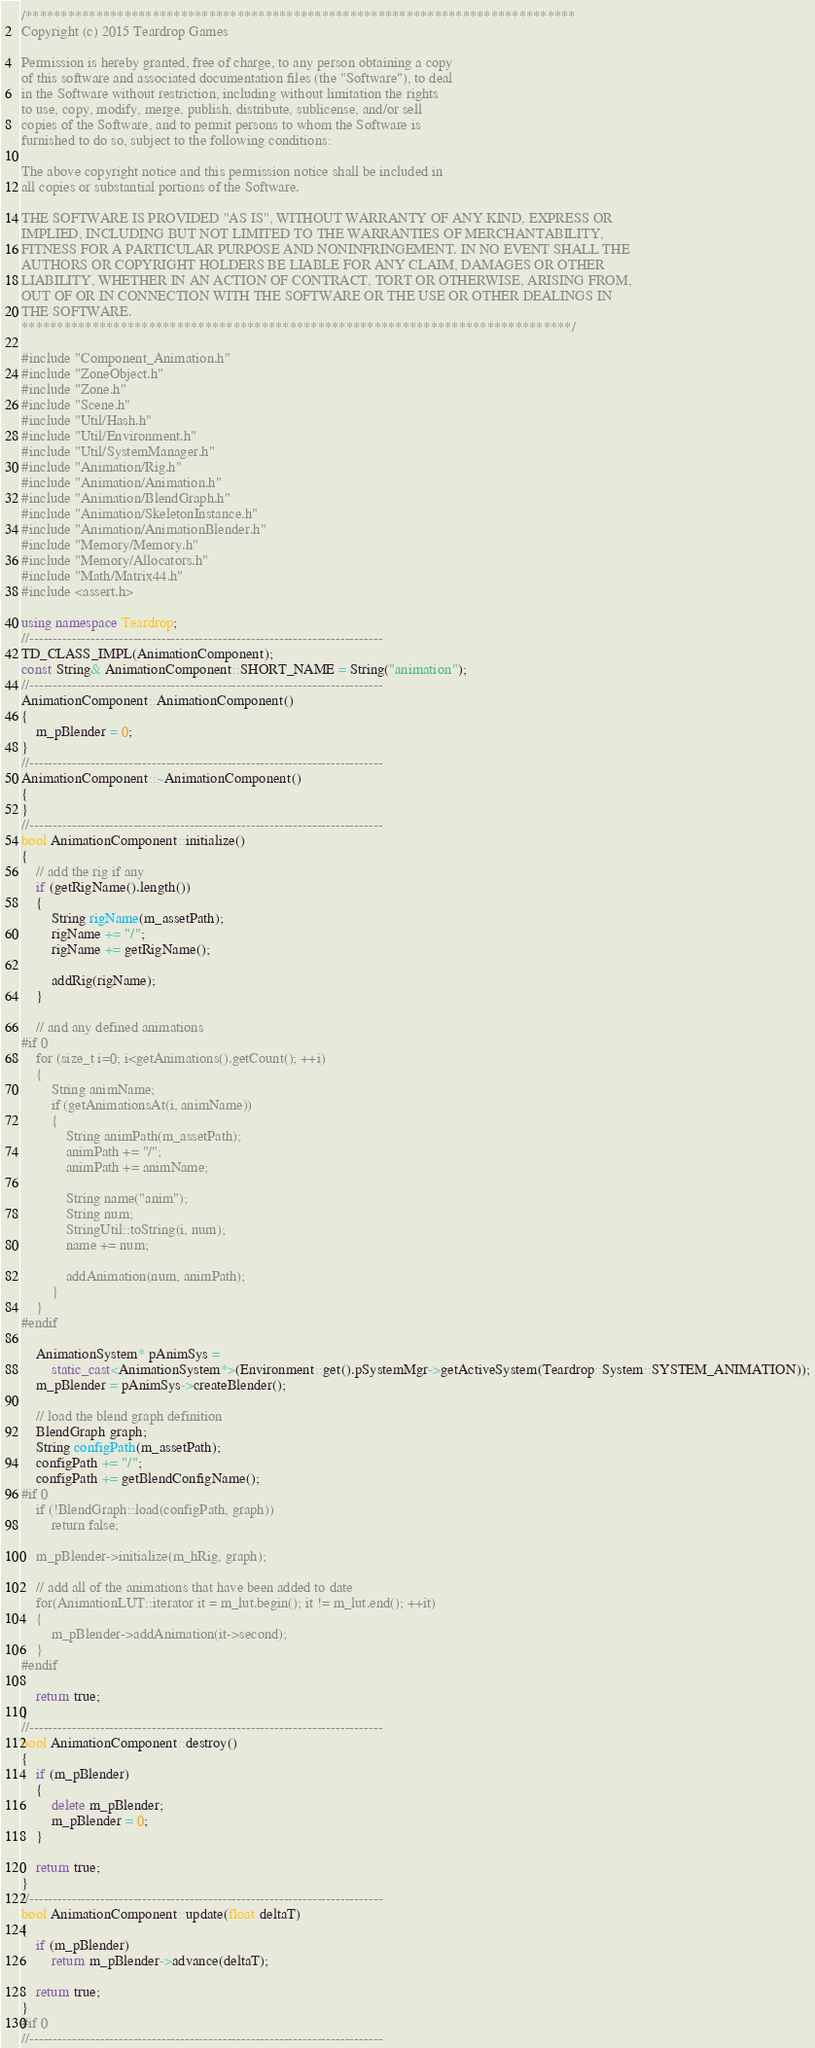<code> <loc_0><loc_0><loc_500><loc_500><_C++_>/******************************************************************************
Copyright (c) 2015 Teardrop Games

Permission is hereby granted, free of charge, to any person obtaining a copy
of this software and associated documentation files (the "Software"), to deal
in the Software without restriction, including without limitation the rights
to use, copy, modify, merge, publish, distribute, sublicense, and/or sell
copies of the Software, and to permit persons to whom the Software is
furnished to do so, subject to the following conditions:

The above copyright notice and this permission notice shall be included in
all copies or substantial portions of the Software.

THE SOFTWARE IS PROVIDED "AS IS", WITHOUT WARRANTY OF ANY KIND, EXPRESS OR
IMPLIED, INCLUDING BUT NOT LIMITED TO THE WARRANTIES OF MERCHANTABILITY,
FITNESS FOR A PARTICULAR PURPOSE AND NONINFRINGEMENT. IN NO EVENT SHALL THE
AUTHORS OR COPYRIGHT HOLDERS BE LIABLE FOR ANY CLAIM, DAMAGES OR OTHER
LIABILITY, WHETHER IN AN ACTION OF CONTRACT, TORT OR OTHERWISE, ARISING FROM,
OUT OF OR IN CONNECTION WITH THE SOFTWARE OR THE USE OR OTHER DEALINGS IN
THE SOFTWARE.
******************************************************************************/

#include "Component_Animation.h"
#include "ZoneObject.h"
#include "Zone.h"
#include "Scene.h"
#include "Util/Hash.h"
#include "Util/Environment.h"
#include "Util/SystemManager.h"
#include "Animation/Rig.h"
#include "Animation/Animation.h"
#include "Animation/BlendGraph.h"
#include "Animation/SkeletonInstance.h"
#include "Animation/AnimationBlender.h"
#include "Memory/Memory.h"
#include "Memory/Allocators.h"
#include "Math/Matrix44.h"
#include <assert.h>

using namespace Teardrop;
//---------------------------------------------------------------------------
TD_CLASS_IMPL(AnimationComponent);
const String& AnimationComponent::SHORT_NAME = String("animation");
//---------------------------------------------------------------------------
AnimationComponent::AnimationComponent()
{
	m_pBlender = 0;
}
//---------------------------------------------------------------------------
AnimationComponent::~AnimationComponent()
{
}
//---------------------------------------------------------------------------
bool AnimationComponent::initialize()
{
	// add the rig if any
	if (getRigName().length())
	{
		String rigName(m_assetPath);
		rigName += "/";
		rigName += getRigName();

		addRig(rigName);
	}

	// and any defined animations
#if 0
	for (size_t i=0; i<getAnimations().getCount(); ++i)
	{
		String animName;
		if (getAnimationsAt(i, animName))
		{
			String animPath(m_assetPath);
			animPath += "/";
			animPath += animName;

			String name("anim");
			String num;
			StringUtil::toString(i, num);
			name += num;

			addAnimation(num, animPath);
		}
	}
#endif

	AnimationSystem* pAnimSys = 
		static_cast<AnimationSystem*>(Environment::get().pSystemMgr->getActiveSystem(Teardrop::System::SYSTEM_ANIMATION));
	m_pBlender = pAnimSys->createBlender();

	// load the blend graph definition
	BlendGraph graph;
	String configPath(m_assetPath);
	configPath += "/";
	configPath += getBlendConfigName();
#if 0
    if (!BlendGraph::load(configPath, graph))
		return false;

	m_pBlender->initialize(m_hRig, graph);

	// add all of the animations that have been added to date
	for(AnimationLUT::iterator it = m_lut.begin(); it != m_lut.end(); ++it)
	{
		m_pBlender->addAnimation(it->second);
	}
#endif

	return true;
}
//---------------------------------------------------------------------------
bool AnimationComponent::destroy()
{
	if (m_pBlender)
	{
		delete m_pBlender;
		m_pBlender = 0;
	}

	return true;
}
//---------------------------------------------------------------------------
bool AnimationComponent::update(float deltaT)
{
	if (m_pBlender)
		return m_pBlender->advance(deltaT);

	return true;
}
#if 0
//---------------------------------------------------------------------------</code> 